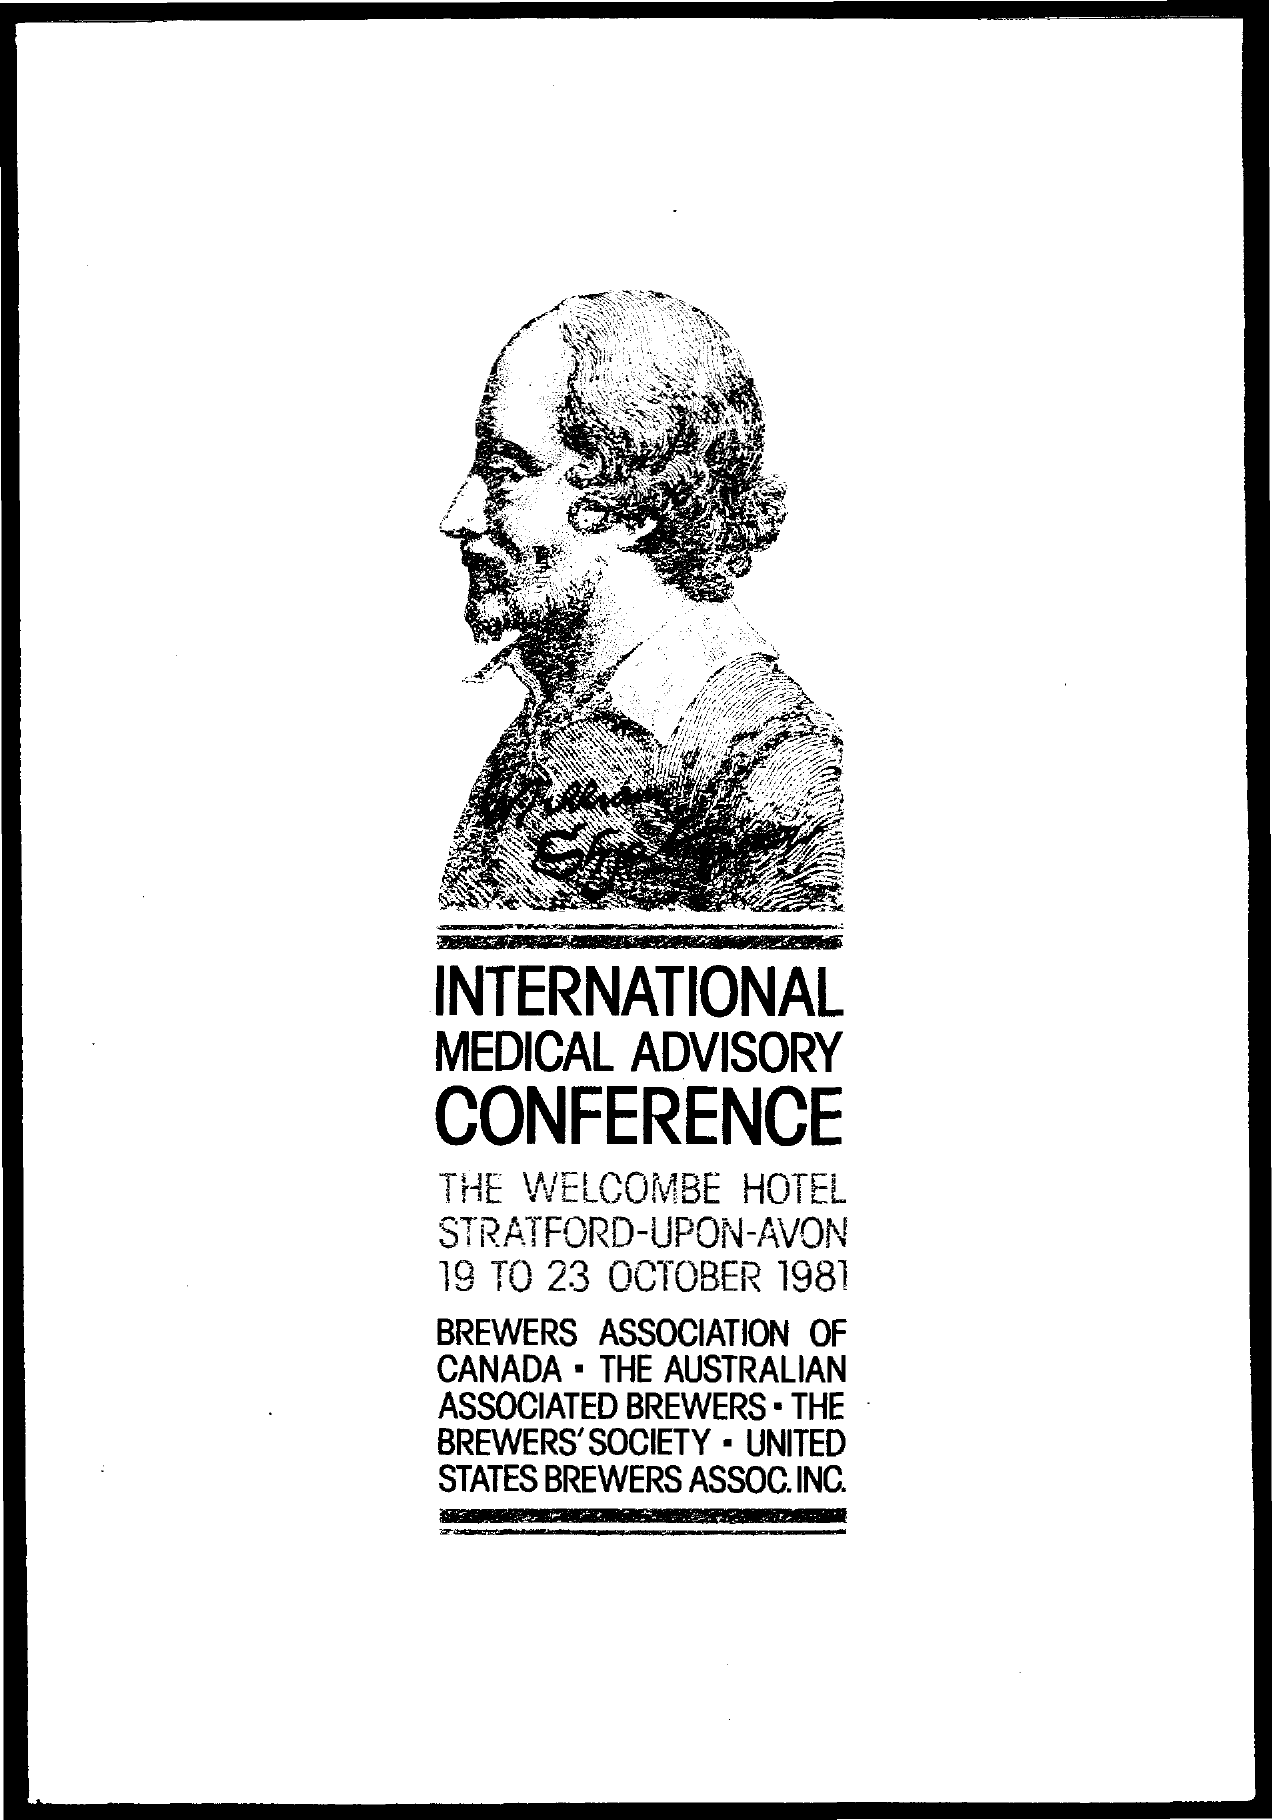Indicate a few pertinent items in this graphic. The International Medical Advisory Conference was held from 19 to 23 October 1981. 